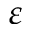Convert formula to latex. <formula><loc_0><loc_0><loc_500><loc_500>\varepsilon</formula> 